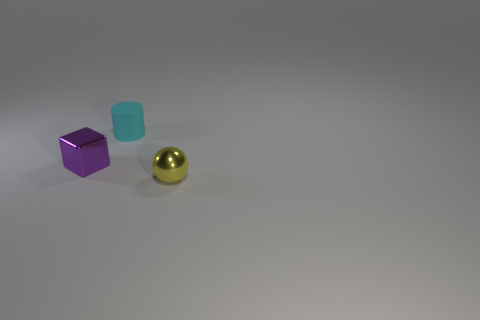Add 3 green matte cylinders. How many objects exist? 6 Subtract all cylinders. How many objects are left? 2 Add 3 tiny rubber objects. How many tiny rubber objects are left? 4 Add 2 purple metal blocks. How many purple metal blocks exist? 3 Subtract 0 green cubes. How many objects are left? 3 Subtract all purple shiny things. Subtract all tiny purple things. How many objects are left? 1 